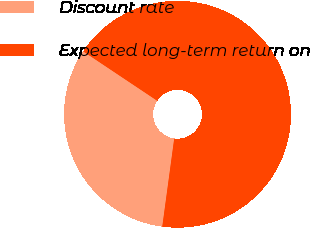<chart> <loc_0><loc_0><loc_500><loc_500><pie_chart><fcel>Discount rate<fcel>Expected long-term return on<nl><fcel>32.22%<fcel>67.78%<nl></chart> 